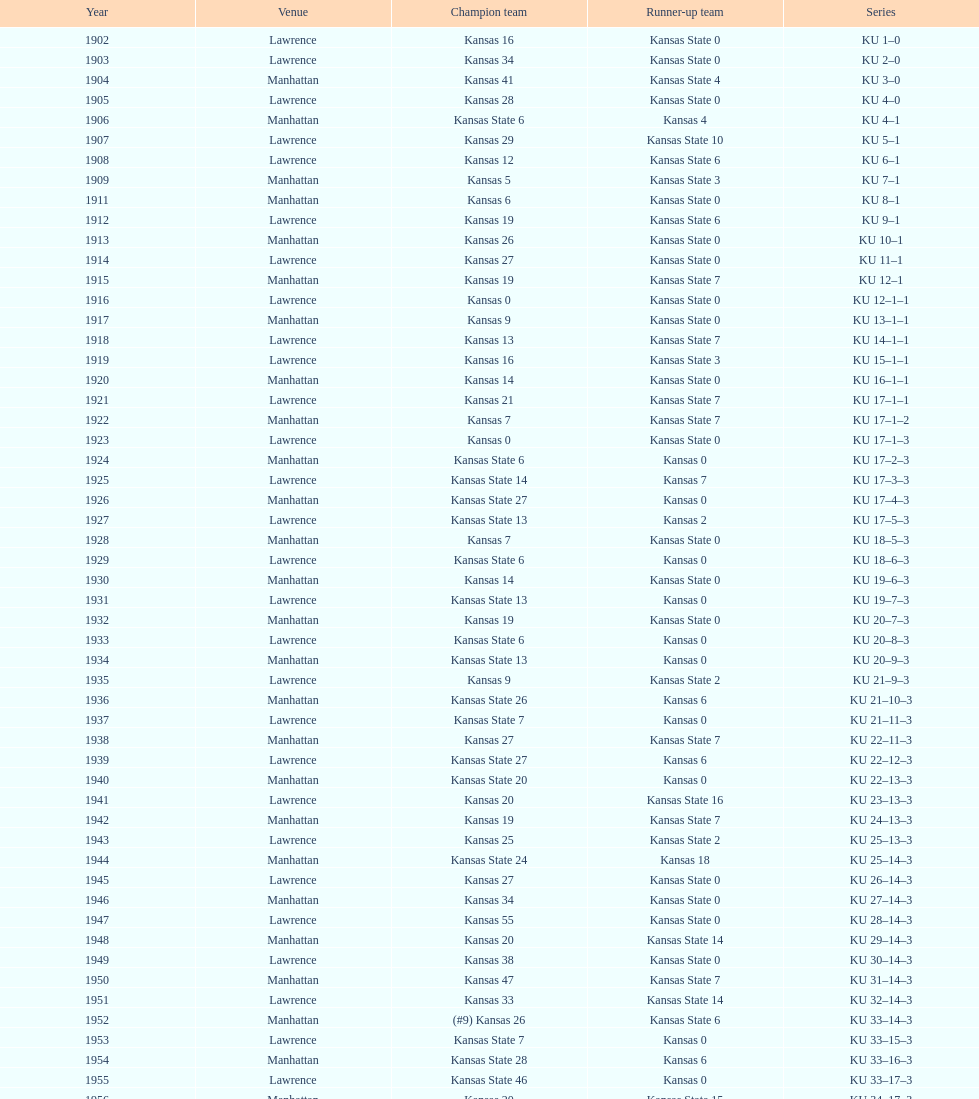What is the total number of games played? 66. 